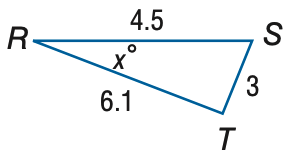Question: Find x. Round to the nearest degree.
Choices:
A. 18
B. 23
C. 28
D. 33
Answer with the letter. Answer: C 